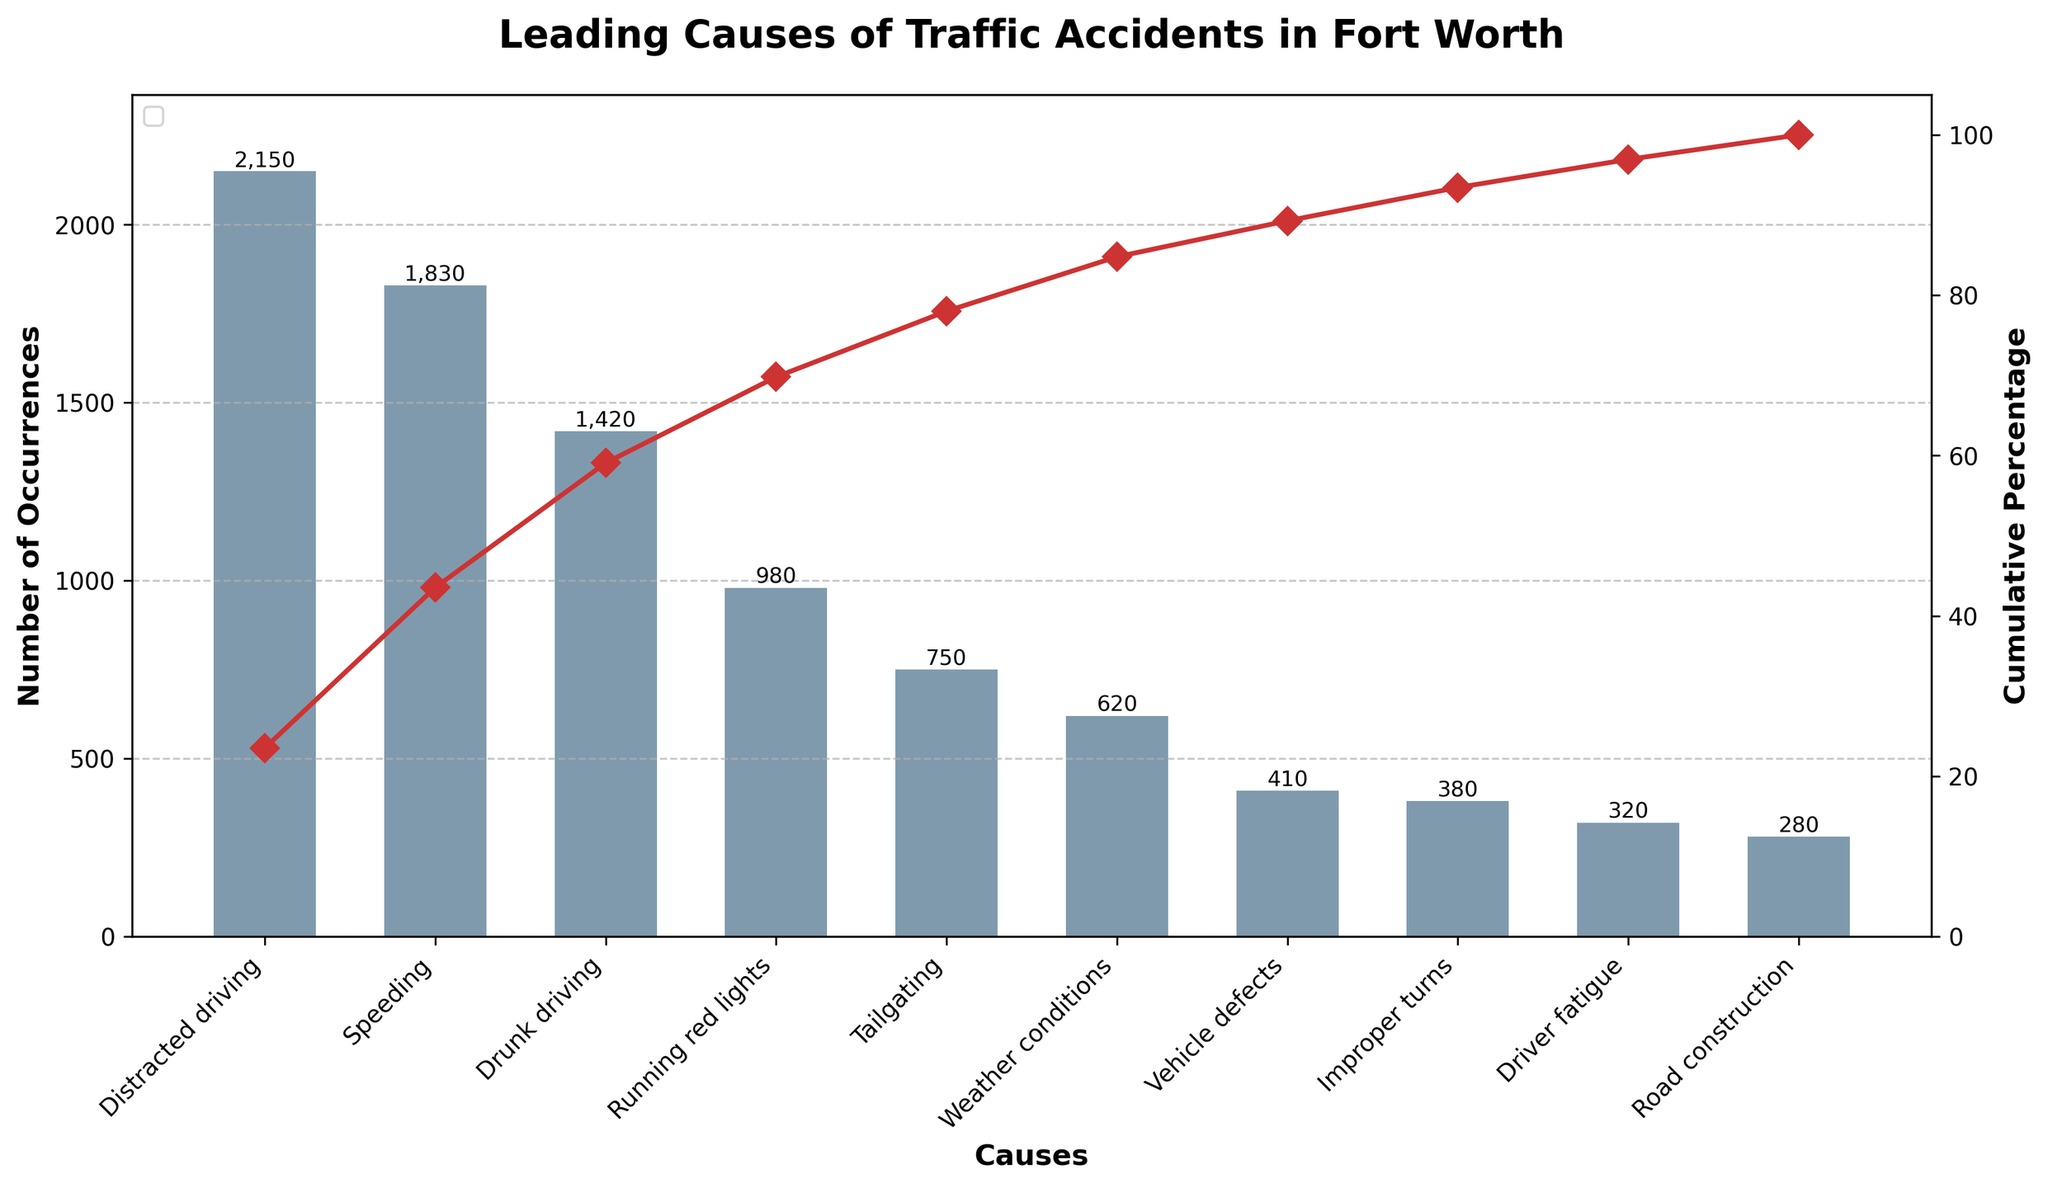What's the title of the chart? The title is prominently featured at the top center of the chart, making it easy to identify.
Answer: Leading Causes of Traffic Accidents in Fort Worth How many causes are represented in the figure? By counting each bar on the x-axis, we determine the number of causes represented.
Answer: 10 Which cause has the highest number of occurrences? The bar with the greatest height on the left-most side indicates the cause with the highest number of occurrences.
Answer: Distracted driving What is the cumulative percentage for speeding? By following the plot line that represents cumulative percentage up from 'Speeding' on the x-axis, we can read the value on the y-axis corresponding to the secondary y-axis.
Answer: Approximately 48.5% What percentage of occurrences do the top three causes account for? Sum the occurrences of the top three causes (Distracted driving: 2150, Speeding: 1830, Drunk driving: 1420) and divide by the total occurrences, then multiply by 100 to get the percentage.
Answer: (2150 + 1830 + 1420) / (2150 + 1830 + 1420 + 980 + 750 + 620 + 410 + 380 + 320 + 280) * 100 ≈ 63.6% Is the cumulative percentage for running red lights greater than 50%? Locate 'Running red lights' on the x-axis and follow the plot line upward to check the cumulative percentage on the secondary y-axis.
Answer: No What cause has a cumulative percentage close to 80%? Follow the plot line till it intersects approximately 80% on the secondary y-axis and read the corresponding cause on the x-axis.
Answer: Tailgating Which cause has the least number of occurrences? The shortest bar on the chart represents the cause with the least number of occurrences.
Answer: Road construction How does the cumulative percentage change between vehicle defects and improper turns? Identify the cumulative percentages for both 'Vehicle defects' and 'Improper turns' on the line chart, then calculate the difference.
Answer: Approximately 6% Do the top five causes account for more than 75% of the total occurrences? Sum the occurrences of the top five causes and divide by the total occurrences, then multiply by 100 to get the percentage.
Answer: (2150 + 1830 + 1420 + 980 + 750) / (2150 + 1830 + 1420 + 980 + 750 + 620 + 410 + 380 + 320 + 280) * 100 ≈ 76.5% 